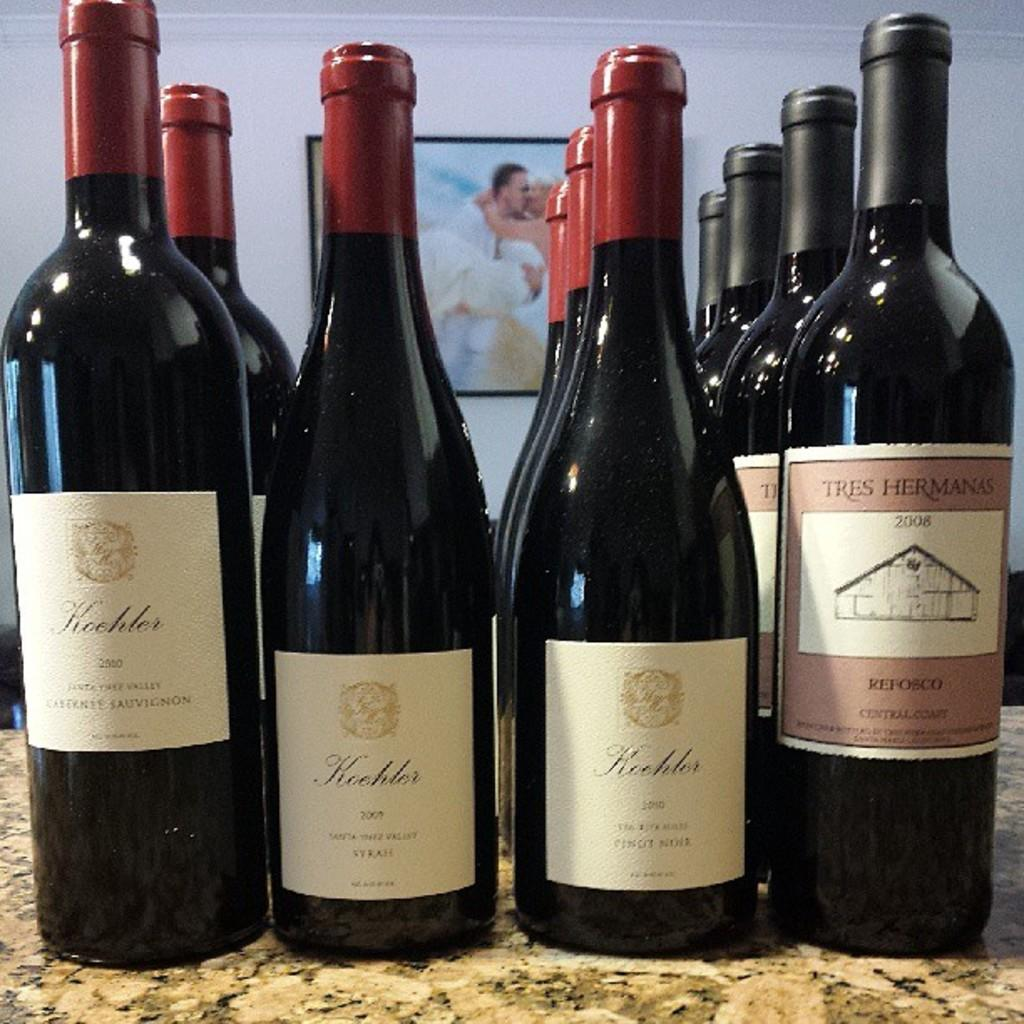What objects can be seen in the image? There are bottles in the image. Where are the bottles located in relation to other objects? The bottles are in front of a wall. What can be seen on the wall in the image? There is a photo frame on the wall. What type of corn can be seen in the image? There is no corn present in the image. 